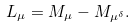<formula> <loc_0><loc_0><loc_500><loc_500>L _ { \mu } = M _ { \mu } - M _ { \mu ^ { \delta } } .</formula> 